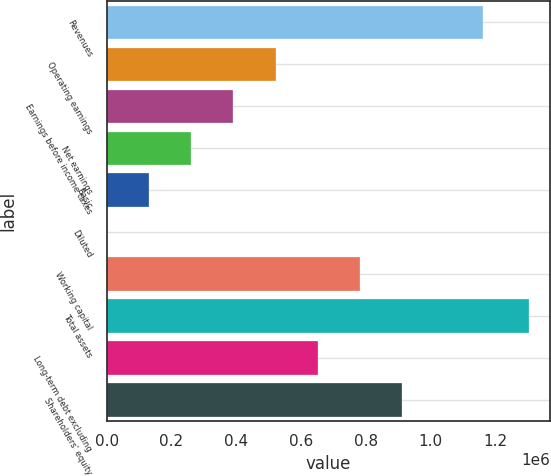Convert chart. <chart><loc_0><loc_0><loc_500><loc_500><bar_chart><fcel>Revenues<fcel>Operating earnings<fcel>Earnings before income taxes<fcel>Net earnings<fcel>Basic<fcel>Diluted<fcel>Working capital<fcel>Total assets<fcel>Long-term debt excluding<fcel>Shareholders' equity<nl><fcel>1.16078e+06<fcel>521452<fcel>391089<fcel>260727<fcel>130364<fcel>1.1<fcel>782178<fcel>1.30363e+06<fcel>651815<fcel>912541<nl></chart> 